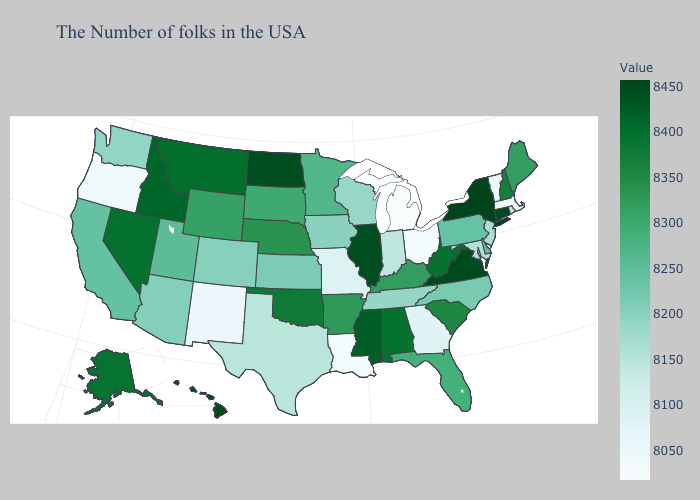Which states have the lowest value in the USA?
Short answer required. Michigan. Does Michigan have the lowest value in the USA?
Answer briefly. Yes. Does Michigan have the lowest value in the MidWest?
Answer briefly. Yes. Does Michigan have the lowest value in the USA?
Keep it brief. Yes. Among the states that border Oregon , does Washington have the lowest value?
Give a very brief answer. Yes. 